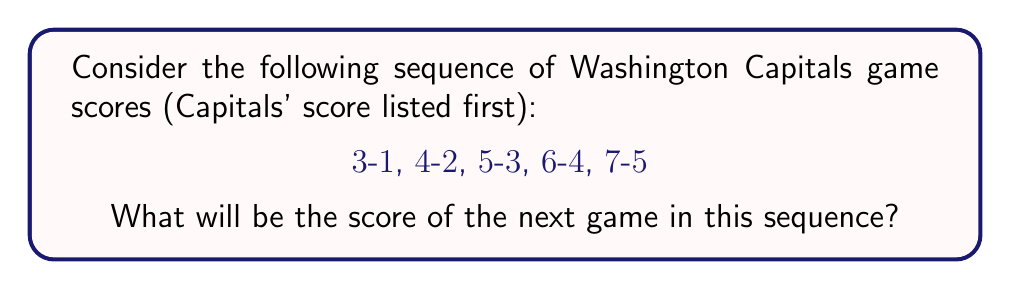What is the answer to this math problem? Let's analyze the pattern step-by-step:

1) First, let's look at the Capitals' scores:
   3, 4, 5, 6, 7

   We can see that the Capitals' score is increasing by 1 each game.

2) Now, let's examine the opponents' scores:
   1, 2, 3, 4, 5

   The opponents' score is also increasing by 1 each game.

3) We can represent this pattern mathematically:
   For the $n$-th game in the sequence:
   Capitals' score: $C_n = n + 2$
   Opponent's score: $O_n = n$

4) To find the next game's score, we need to calculate the 6th game in the sequence:
   Capitals' score: $C_6 = 6 + 2 = 8$
   Opponent's score: $O_6 = 6$

5) Therefore, the next game score in the sequence will be 8-6.
Answer: 8-6 